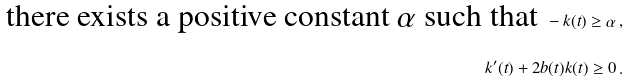<formula> <loc_0><loc_0><loc_500><loc_500>\text {there exists a positive constant $\alpha$ such that } - k ( t ) \geq \alpha \, , \\ k ^ { \prime } ( t ) + 2 b ( t ) k ( t ) \geq 0 \, .</formula> 